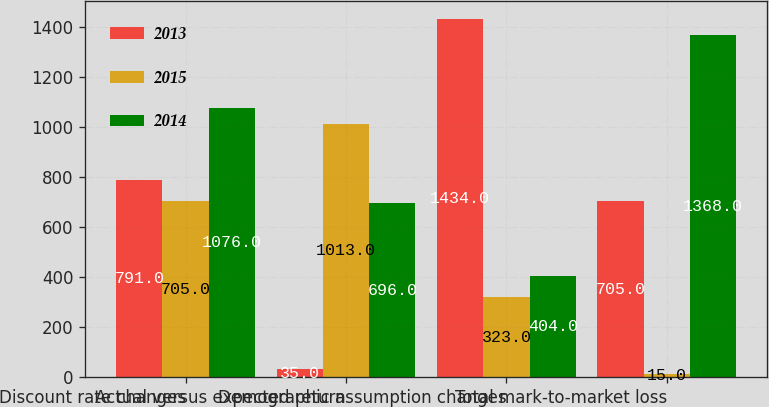Convert chart. <chart><loc_0><loc_0><loc_500><loc_500><stacked_bar_chart><ecel><fcel>Discount rate changes<fcel>Actual versus expected return<fcel>Demographic assumption changes<fcel>Total mark-to-market loss<nl><fcel>2013<fcel>791<fcel>35<fcel>1434<fcel>705<nl><fcel>2015<fcel>705<fcel>1013<fcel>323<fcel>15<nl><fcel>2014<fcel>1076<fcel>696<fcel>404<fcel>1368<nl></chart> 